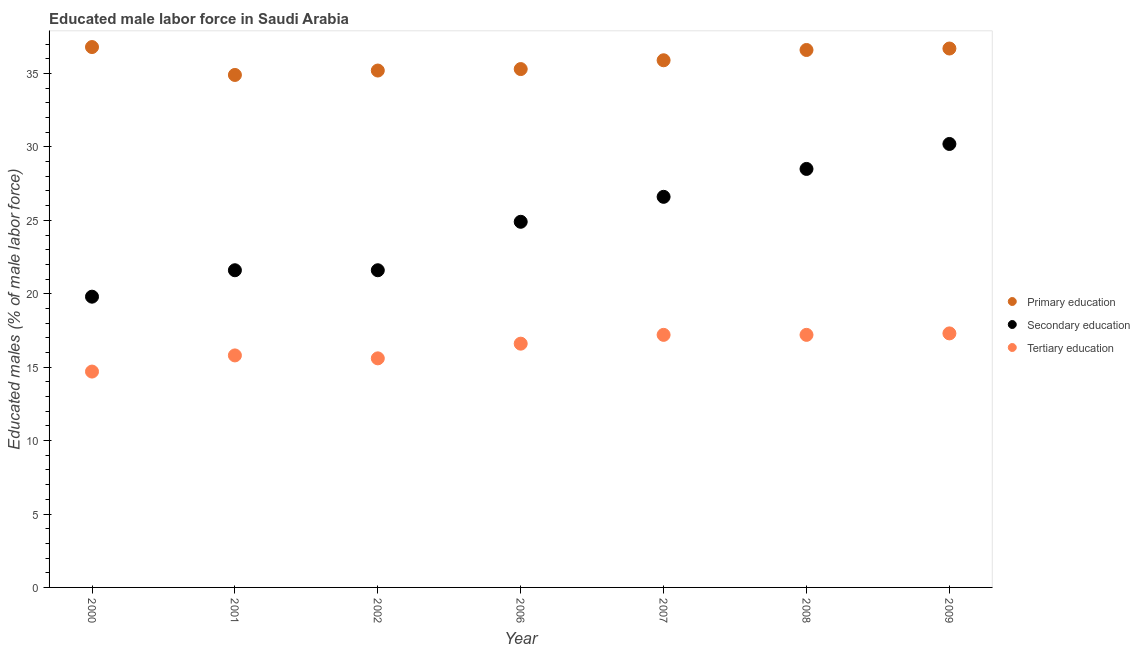Is the number of dotlines equal to the number of legend labels?
Provide a succinct answer. Yes. What is the percentage of male labor force who received primary education in 2002?
Provide a short and direct response. 35.2. Across all years, what is the maximum percentage of male labor force who received primary education?
Make the answer very short. 36.8. Across all years, what is the minimum percentage of male labor force who received secondary education?
Your answer should be compact. 19.8. In which year was the percentage of male labor force who received secondary education maximum?
Keep it short and to the point. 2009. In which year was the percentage of male labor force who received secondary education minimum?
Give a very brief answer. 2000. What is the total percentage of male labor force who received primary education in the graph?
Offer a very short reply. 251.4. What is the difference between the percentage of male labor force who received primary education in 2002 and that in 2006?
Offer a very short reply. -0.1. What is the difference between the percentage of male labor force who received tertiary education in 2007 and the percentage of male labor force who received primary education in 2002?
Ensure brevity in your answer.  -18. What is the average percentage of male labor force who received tertiary education per year?
Make the answer very short. 16.34. In the year 2000, what is the difference between the percentage of male labor force who received tertiary education and percentage of male labor force who received secondary education?
Keep it short and to the point. -5.1. In how many years, is the percentage of male labor force who received tertiary education greater than 13 %?
Offer a very short reply. 7. What is the ratio of the percentage of male labor force who received secondary education in 2002 to that in 2008?
Make the answer very short. 0.76. Is the percentage of male labor force who received secondary education in 2006 less than that in 2009?
Keep it short and to the point. Yes. Is the difference between the percentage of male labor force who received tertiary education in 2006 and 2008 greater than the difference between the percentage of male labor force who received secondary education in 2006 and 2008?
Offer a terse response. Yes. What is the difference between the highest and the second highest percentage of male labor force who received primary education?
Give a very brief answer. 0.1. What is the difference between the highest and the lowest percentage of male labor force who received primary education?
Make the answer very short. 1.9. Is the percentage of male labor force who received secondary education strictly less than the percentage of male labor force who received tertiary education over the years?
Provide a short and direct response. No. How many dotlines are there?
Your response must be concise. 3. Are the values on the major ticks of Y-axis written in scientific E-notation?
Give a very brief answer. No. Does the graph contain grids?
Offer a very short reply. No. Where does the legend appear in the graph?
Your answer should be compact. Center right. How are the legend labels stacked?
Make the answer very short. Vertical. What is the title of the graph?
Your answer should be very brief. Educated male labor force in Saudi Arabia. Does "Domestic" appear as one of the legend labels in the graph?
Give a very brief answer. No. What is the label or title of the X-axis?
Provide a short and direct response. Year. What is the label or title of the Y-axis?
Give a very brief answer. Educated males (% of male labor force). What is the Educated males (% of male labor force) of Primary education in 2000?
Your response must be concise. 36.8. What is the Educated males (% of male labor force) in Secondary education in 2000?
Your answer should be compact. 19.8. What is the Educated males (% of male labor force) in Tertiary education in 2000?
Ensure brevity in your answer.  14.7. What is the Educated males (% of male labor force) of Primary education in 2001?
Your answer should be compact. 34.9. What is the Educated males (% of male labor force) of Secondary education in 2001?
Your answer should be compact. 21.6. What is the Educated males (% of male labor force) in Tertiary education in 2001?
Make the answer very short. 15.8. What is the Educated males (% of male labor force) of Primary education in 2002?
Your answer should be compact. 35.2. What is the Educated males (% of male labor force) of Secondary education in 2002?
Provide a succinct answer. 21.6. What is the Educated males (% of male labor force) in Tertiary education in 2002?
Provide a succinct answer. 15.6. What is the Educated males (% of male labor force) in Primary education in 2006?
Your answer should be very brief. 35.3. What is the Educated males (% of male labor force) in Secondary education in 2006?
Give a very brief answer. 24.9. What is the Educated males (% of male labor force) of Tertiary education in 2006?
Provide a short and direct response. 16.6. What is the Educated males (% of male labor force) in Primary education in 2007?
Your response must be concise. 35.9. What is the Educated males (% of male labor force) in Secondary education in 2007?
Make the answer very short. 26.6. What is the Educated males (% of male labor force) of Tertiary education in 2007?
Your answer should be very brief. 17.2. What is the Educated males (% of male labor force) of Primary education in 2008?
Offer a very short reply. 36.6. What is the Educated males (% of male labor force) of Secondary education in 2008?
Keep it short and to the point. 28.5. What is the Educated males (% of male labor force) of Tertiary education in 2008?
Your answer should be compact. 17.2. What is the Educated males (% of male labor force) in Primary education in 2009?
Keep it short and to the point. 36.7. What is the Educated males (% of male labor force) in Secondary education in 2009?
Ensure brevity in your answer.  30.2. What is the Educated males (% of male labor force) of Tertiary education in 2009?
Ensure brevity in your answer.  17.3. Across all years, what is the maximum Educated males (% of male labor force) in Primary education?
Your response must be concise. 36.8. Across all years, what is the maximum Educated males (% of male labor force) of Secondary education?
Ensure brevity in your answer.  30.2. Across all years, what is the maximum Educated males (% of male labor force) in Tertiary education?
Your answer should be compact. 17.3. Across all years, what is the minimum Educated males (% of male labor force) in Primary education?
Keep it short and to the point. 34.9. Across all years, what is the minimum Educated males (% of male labor force) of Secondary education?
Offer a very short reply. 19.8. Across all years, what is the minimum Educated males (% of male labor force) in Tertiary education?
Make the answer very short. 14.7. What is the total Educated males (% of male labor force) in Primary education in the graph?
Your response must be concise. 251.4. What is the total Educated males (% of male labor force) in Secondary education in the graph?
Your response must be concise. 173.2. What is the total Educated males (% of male labor force) in Tertiary education in the graph?
Your answer should be compact. 114.4. What is the difference between the Educated males (% of male labor force) of Tertiary education in 2000 and that in 2002?
Offer a very short reply. -0.9. What is the difference between the Educated males (% of male labor force) in Primary education in 2000 and that in 2007?
Give a very brief answer. 0.9. What is the difference between the Educated males (% of male labor force) of Tertiary education in 2000 and that in 2007?
Your answer should be compact. -2.5. What is the difference between the Educated males (% of male labor force) in Primary education in 2000 and that in 2008?
Your response must be concise. 0.2. What is the difference between the Educated males (% of male labor force) of Tertiary education in 2000 and that in 2008?
Provide a short and direct response. -2.5. What is the difference between the Educated males (% of male labor force) of Primary education in 2000 and that in 2009?
Offer a terse response. 0.1. What is the difference between the Educated males (% of male labor force) in Secondary education in 2000 and that in 2009?
Make the answer very short. -10.4. What is the difference between the Educated males (% of male labor force) of Secondary education in 2001 and that in 2002?
Provide a succinct answer. 0. What is the difference between the Educated males (% of male labor force) in Tertiary education in 2001 and that in 2002?
Ensure brevity in your answer.  0.2. What is the difference between the Educated males (% of male labor force) in Primary education in 2001 and that in 2006?
Make the answer very short. -0.4. What is the difference between the Educated males (% of male labor force) in Primary education in 2001 and that in 2007?
Make the answer very short. -1. What is the difference between the Educated males (% of male labor force) of Secondary education in 2001 and that in 2007?
Your response must be concise. -5. What is the difference between the Educated males (% of male labor force) of Tertiary education in 2001 and that in 2007?
Make the answer very short. -1.4. What is the difference between the Educated males (% of male labor force) of Secondary education in 2001 and that in 2008?
Your answer should be very brief. -6.9. What is the difference between the Educated males (% of male labor force) of Secondary education in 2001 and that in 2009?
Your answer should be compact. -8.6. What is the difference between the Educated males (% of male labor force) of Tertiary education in 2002 and that in 2006?
Keep it short and to the point. -1. What is the difference between the Educated males (% of male labor force) in Primary education in 2002 and that in 2008?
Make the answer very short. -1.4. What is the difference between the Educated males (% of male labor force) in Tertiary education in 2002 and that in 2008?
Your answer should be compact. -1.6. What is the difference between the Educated males (% of male labor force) of Tertiary education in 2002 and that in 2009?
Give a very brief answer. -1.7. What is the difference between the Educated males (% of male labor force) of Secondary education in 2006 and that in 2007?
Provide a short and direct response. -1.7. What is the difference between the Educated males (% of male labor force) of Tertiary education in 2006 and that in 2007?
Your answer should be compact. -0.6. What is the difference between the Educated males (% of male labor force) of Primary education in 2006 and that in 2008?
Give a very brief answer. -1.3. What is the difference between the Educated males (% of male labor force) of Secondary education in 2006 and that in 2008?
Keep it short and to the point. -3.6. What is the difference between the Educated males (% of male labor force) in Primary education in 2007 and that in 2008?
Offer a terse response. -0.7. What is the difference between the Educated males (% of male labor force) of Secondary education in 2007 and that in 2008?
Give a very brief answer. -1.9. What is the difference between the Educated males (% of male labor force) of Tertiary education in 2007 and that in 2008?
Your answer should be compact. 0. What is the difference between the Educated males (% of male labor force) of Primary education in 2007 and that in 2009?
Ensure brevity in your answer.  -0.8. What is the difference between the Educated males (% of male labor force) of Secondary education in 2007 and that in 2009?
Keep it short and to the point. -3.6. What is the difference between the Educated males (% of male labor force) of Primary education in 2008 and that in 2009?
Provide a short and direct response. -0.1. What is the difference between the Educated males (% of male labor force) in Secondary education in 2008 and that in 2009?
Your response must be concise. -1.7. What is the difference between the Educated males (% of male labor force) in Primary education in 2000 and the Educated males (% of male labor force) in Secondary education in 2001?
Offer a terse response. 15.2. What is the difference between the Educated males (% of male labor force) of Primary education in 2000 and the Educated males (% of male labor force) of Tertiary education in 2001?
Make the answer very short. 21. What is the difference between the Educated males (% of male labor force) in Secondary education in 2000 and the Educated males (% of male labor force) in Tertiary education in 2001?
Keep it short and to the point. 4. What is the difference between the Educated males (% of male labor force) in Primary education in 2000 and the Educated males (% of male labor force) in Tertiary education in 2002?
Keep it short and to the point. 21.2. What is the difference between the Educated males (% of male labor force) of Secondary education in 2000 and the Educated males (% of male labor force) of Tertiary education in 2002?
Make the answer very short. 4.2. What is the difference between the Educated males (% of male labor force) in Primary education in 2000 and the Educated males (% of male labor force) in Tertiary education in 2006?
Keep it short and to the point. 20.2. What is the difference between the Educated males (% of male labor force) in Secondary education in 2000 and the Educated males (% of male labor force) in Tertiary education in 2006?
Your answer should be very brief. 3.2. What is the difference between the Educated males (% of male labor force) of Primary education in 2000 and the Educated males (% of male labor force) of Tertiary education in 2007?
Provide a succinct answer. 19.6. What is the difference between the Educated males (% of male labor force) in Secondary education in 2000 and the Educated males (% of male labor force) in Tertiary education in 2007?
Offer a terse response. 2.6. What is the difference between the Educated males (% of male labor force) of Primary education in 2000 and the Educated males (% of male labor force) of Tertiary education in 2008?
Your answer should be very brief. 19.6. What is the difference between the Educated males (% of male labor force) in Secondary education in 2000 and the Educated males (% of male labor force) in Tertiary education in 2008?
Keep it short and to the point. 2.6. What is the difference between the Educated males (% of male labor force) of Primary education in 2000 and the Educated males (% of male labor force) of Secondary education in 2009?
Keep it short and to the point. 6.6. What is the difference between the Educated males (% of male labor force) in Primary education in 2000 and the Educated males (% of male labor force) in Tertiary education in 2009?
Your response must be concise. 19.5. What is the difference between the Educated males (% of male labor force) of Secondary education in 2000 and the Educated males (% of male labor force) of Tertiary education in 2009?
Provide a succinct answer. 2.5. What is the difference between the Educated males (% of male labor force) in Primary education in 2001 and the Educated males (% of male labor force) in Tertiary education in 2002?
Your answer should be very brief. 19.3. What is the difference between the Educated males (% of male labor force) in Secondary education in 2001 and the Educated males (% of male labor force) in Tertiary education in 2002?
Make the answer very short. 6. What is the difference between the Educated males (% of male labor force) in Primary education in 2001 and the Educated males (% of male labor force) in Tertiary education in 2006?
Ensure brevity in your answer.  18.3. What is the difference between the Educated males (% of male labor force) in Primary education in 2001 and the Educated males (% of male labor force) in Secondary education in 2007?
Your response must be concise. 8.3. What is the difference between the Educated males (% of male labor force) in Primary education in 2001 and the Educated males (% of male labor force) in Tertiary education in 2007?
Give a very brief answer. 17.7. What is the difference between the Educated males (% of male labor force) in Primary education in 2001 and the Educated males (% of male labor force) in Secondary education in 2008?
Your answer should be very brief. 6.4. What is the difference between the Educated males (% of male labor force) in Primary education in 2001 and the Educated males (% of male labor force) in Tertiary education in 2008?
Offer a terse response. 17.7. What is the difference between the Educated males (% of male labor force) in Secondary education in 2001 and the Educated males (% of male labor force) in Tertiary education in 2008?
Make the answer very short. 4.4. What is the difference between the Educated males (% of male labor force) in Primary education in 2001 and the Educated males (% of male labor force) in Secondary education in 2009?
Your response must be concise. 4.7. What is the difference between the Educated males (% of male labor force) in Primary education in 2001 and the Educated males (% of male labor force) in Tertiary education in 2009?
Offer a very short reply. 17.6. What is the difference between the Educated males (% of male labor force) of Secondary education in 2001 and the Educated males (% of male labor force) of Tertiary education in 2009?
Your response must be concise. 4.3. What is the difference between the Educated males (% of male labor force) of Primary education in 2002 and the Educated males (% of male labor force) of Secondary education in 2006?
Make the answer very short. 10.3. What is the difference between the Educated males (% of male labor force) in Primary education in 2002 and the Educated males (% of male labor force) in Tertiary education in 2006?
Your answer should be compact. 18.6. What is the difference between the Educated males (% of male labor force) in Primary education in 2002 and the Educated males (% of male labor force) in Tertiary education in 2007?
Offer a very short reply. 18. What is the difference between the Educated males (% of male labor force) in Secondary education in 2002 and the Educated males (% of male labor force) in Tertiary education in 2007?
Make the answer very short. 4.4. What is the difference between the Educated males (% of male labor force) of Primary education in 2002 and the Educated males (% of male labor force) of Secondary education in 2008?
Give a very brief answer. 6.7. What is the difference between the Educated males (% of male labor force) in Primary education in 2002 and the Educated males (% of male labor force) in Secondary education in 2009?
Offer a very short reply. 5. What is the difference between the Educated males (% of male labor force) of Primary education in 2002 and the Educated males (% of male labor force) of Tertiary education in 2009?
Offer a terse response. 17.9. What is the difference between the Educated males (% of male labor force) of Secondary education in 2002 and the Educated males (% of male labor force) of Tertiary education in 2009?
Offer a terse response. 4.3. What is the difference between the Educated males (% of male labor force) of Primary education in 2006 and the Educated males (% of male labor force) of Tertiary education in 2007?
Provide a short and direct response. 18.1. What is the difference between the Educated males (% of male labor force) of Secondary education in 2006 and the Educated males (% of male labor force) of Tertiary education in 2007?
Ensure brevity in your answer.  7.7. What is the difference between the Educated males (% of male labor force) in Primary education in 2006 and the Educated males (% of male labor force) in Secondary education in 2008?
Keep it short and to the point. 6.8. What is the difference between the Educated males (% of male labor force) in Primary education in 2006 and the Educated males (% of male labor force) in Tertiary education in 2009?
Provide a short and direct response. 18. What is the difference between the Educated males (% of male labor force) in Secondary education in 2006 and the Educated males (% of male labor force) in Tertiary education in 2009?
Offer a very short reply. 7.6. What is the difference between the Educated males (% of male labor force) of Primary education in 2007 and the Educated males (% of male labor force) of Secondary education in 2008?
Offer a very short reply. 7.4. What is the difference between the Educated males (% of male labor force) in Secondary education in 2007 and the Educated males (% of male labor force) in Tertiary education in 2008?
Your answer should be compact. 9.4. What is the difference between the Educated males (% of male labor force) in Secondary education in 2007 and the Educated males (% of male labor force) in Tertiary education in 2009?
Your answer should be compact. 9.3. What is the difference between the Educated males (% of male labor force) of Primary education in 2008 and the Educated males (% of male labor force) of Secondary education in 2009?
Offer a very short reply. 6.4. What is the difference between the Educated males (% of male labor force) in Primary education in 2008 and the Educated males (% of male labor force) in Tertiary education in 2009?
Make the answer very short. 19.3. What is the average Educated males (% of male labor force) of Primary education per year?
Ensure brevity in your answer.  35.91. What is the average Educated males (% of male labor force) in Secondary education per year?
Keep it short and to the point. 24.74. What is the average Educated males (% of male labor force) in Tertiary education per year?
Keep it short and to the point. 16.34. In the year 2000, what is the difference between the Educated males (% of male labor force) in Primary education and Educated males (% of male labor force) in Tertiary education?
Provide a succinct answer. 22.1. In the year 2000, what is the difference between the Educated males (% of male labor force) in Secondary education and Educated males (% of male labor force) in Tertiary education?
Your response must be concise. 5.1. In the year 2001, what is the difference between the Educated males (% of male labor force) of Primary education and Educated males (% of male labor force) of Secondary education?
Ensure brevity in your answer.  13.3. In the year 2001, what is the difference between the Educated males (% of male labor force) in Secondary education and Educated males (% of male labor force) in Tertiary education?
Offer a terse response. 5.8. In the year 2002, what is the difference between the Educated males (% of male labor force) in Primary education and Educated males (% of male labor force) in Secondary education?
Make the answer very short. 13.6. In the year 2002, what is the difference between the Educated males (% of male labor force) in Primary education and Educated males (% of male labor force) in Tertiary education?
Make the answer very short. 19.6. In the year 2002, what is the difference between the Educated males (% of male labor force) of Secondary education and Educated males (% of male labor force) of Tertiary education?
Provide a short and direct response. 6. In the year 2006, what is the difference between the Educated males (% of male labor force) in Primary education and Educated males (% of male labor force) in Secondary education?
Your answer should be compact. 10.4. In the year 2007, what is the difference between the Educated males (% of male labor force) in Primary education and Educated males (% of male labor force) in Tertiary education?
Your answer should be very brief. 18.7. In the year 2007, what is the difference between the Educated males (% of male labor force) in Secondary education and Educated males (% of male labor force) in Tertiary education?
Provide a succinct answer. 9.4. In the year 2009, what is the difference between the Educated males (% of male labor force) of Primary education and Educated males (% of male labor force) of Secondary education?
Make the answer very short. 6.5. In the year 2009, what is the difference between the Educated males (% of male labor force) of Primary education and Educated males (% of male labor force) of Tertiary education?
Ensure brevity in your answer.  19.4. In the year 2009, what is the difference between the Educated males (% of male labor force) of Secondary education and Educated males (% of male labor force) of Tertiary education?
Ensure brevity in your answer.  12.9. What is the ratio of the Educated males (% of male labor force) in Primary education in 2000 to that in 2001?
Make the answer very short. 1.05. What is the ratio of the Educated males (% of male labor force) in Tertiary education in 2000 to that in 2001?
Your answer should be very brief. 0.93. What is the ratio of the Educated males (% of male labor force) of Primary education in 2000 to that in 2002?
Make the answer very short. 1.05. What is the ratio of the Educated males (% of male labor force) of Secondary education in 2000 to that in 2002?
Ensure brevity in your answer.  0.92. What is the ratio of the Educated males (% of male labor force) in Tertiary education in 2000 to that in 2002?
Make the answer very short. 0.94. What is the ratio of the Educated males (% of male labor force) in Primary education in 2000 to that in 2006?
Offer a terse response. 1.04. What is the ratio of the Educated males (% of male labor force) of Secondary education in 2000 to that in 2006?
Your answer should be compact. 0.8. What is the ratio of the Educated males (% of male labor force) in Tertiary education in 2000 to that in 2006?
Offer a terse response. 0.89. What is the ratio of the Educated males (% of male labor force) of Primary education in 2000 to that in 2007?
Offer a terse response. 1.03. What is the ratio of the Educated males (% of male labor force) in Secondary education in 2000 to that in 2007?
Give a very brief answer. 0.74. What is the ratio of the Educated males (% of male labor force) of Tertiary education in 2000 to that in 2007?
Offer a terse response. 0.85. What is the ratio of the Educated males (% of male labor force) of Primary education in 2000 to that in 2008?
Your response must be concise. 1.01. What is the ratio of the Educated males (% of male labor force) in Secondary education in 2000 to that in 2008?
Your answer should be compact. 0.69. What is the ratio of the Educated males (% of male labor force) of Tertiary education in 2000 to that in 2008?
Provide a short and direct response. 0.85. What is the ratio of the Educated males (% of male labor force) of Primary education in 2000 to that in 2009?
Provide a succinct answer. 1. What is the ratio of the Educated males (% of male labor force) in Secondary education in 2000 to that in 2009?
Make the answer very short. 0.66. What is the ratio of the Educated males (% of male labor force) of Tertiary education in 2000 to that in 2009?
Ensure brevity in your answer.  0.85. What is the ratio of the Educated males (% of male labor force) of Primary education in 2001 to that in 2002?
Your answer should be very brief. 0.99. What is the ratio of the Educated males (% of male labor force) in Tertiary education in 2001 to that in 2002?
Offer a terse response. 1.01. What is the ratio of the Educated males (% of male labor force) of Primary education in 2001 to that in 2006?
Offer a terse response. 0.99. What is the ratio of the Educated males (% of male labor force) in Secondary education in 2001 to that in 2006?
Provide a succinct answer. 0.87. What is the ratio of the Educated males (% of male labor force) of Tertiary education in 2001 to that in 2006?
Make the answer very short. 0.95. What is the ratio of the Educated males (% of male labor force) in Primary education in 2001 to that in 2007?
Provide a succinct answer. 0.97. What is the ratio of the Educated males (% of male labor force) in Secondary education in 2001 to that in 2007?
Provide a succinct answer. 0.81. What is the ratio of the Educated males (% of male labor force) in Tertiary education in 2001 to that in 2007?
Offer a very short reply. 0.92. What is the ratio of the Educated males (% of male labor force) in Primary education in 2001 to that in 2008?
Your response must be concise. 0.95. What is the ratio of the Educated males (% of male labor force) in Secondary education in 2001 to that in 2008?
Your answer should be very brief. 0.76. What is the ratio of the Educated males (% of male labor force) in Tertiary education in 2001 to that in 2008?
Your response must be concise. 0.92. What is the ratio of the Educated males (% of male labor force) in Primary education in 2001 to that in 2009?
Your answer should be very brief. 0.95. What is the ratio of the Educated males (% of male labor force) of Secondary education in 2001 to that in 2009?
Offer a terse response. 0.72. What is the ratio of the Educated males (% of male labor force) in Tertiary education in 2001 to that in 2009?
Provide a succinct answer. 0.91. What is the ratio of the Educated males (% of male labor force) of Secondary education in 2002 to that in 2006?
Ensure brevity in your answer.  0.87. What is the ratio of the Educated males (% of male labor force) in Tertiary education in 2002 to that in 2006?
Offer a terse response. 0.94. What is the ratio of the Educated males (% of male labor force) of Primary education in 2002 to that in 2007?
Your answer should be very brief. 0.98. What is the ratio of the Educated males (% of male labor force) in Secondary education in 2002 to that in 2007?
Your response must be concise. 0.81. What is the ratio of the Educated males (% of male labor force) in Tertiary education in 2002 to that in 2007?
Give a very brief answer. 0.91. What is the ratio of the Educated males (% of male labor force) of Primary education in 2002 to that in 2008?
Offer a very short reply. 0.96. What is the ratio of the Educated males (% of male labor force) of Secondary education in 2002 to that in 2008?
Give a very brief answer. 0.76. What is the ratio of the Educated males (% of male labor force) of Tertiary education in 2002 to that in 2008?
Keep it short and to the point. 0.91. What is the ratio of the Educated males (% of male labor force) in Primary education in 2002 to that in 2009?
Your answer should be very brief. 0.96. What is the ratio of the Educated males (% of male labor force) of Secondary education in 2002 to that in 2009?
Offer a terse response. 0.72. What is the ratio of the Educated males (% of male labor force) in Tertiary education in 2002 to that in 2009?
Your response must be concise. 0.9. What is the ratio of the Educated males (% of male labor force) of Primary education in 2006 to that in 2007?
Your answer should be very brief. 0.98. What is the ratio of the Educated males (% of male labor force) in Secondary education in 2006 to that in 2007?
Offer a very short reply. 0.94. What is the ratio of the Educated males (% of male labor force) in Tertiary education in 2006 to that in 2007?
Provide a short and direct response. 0.97. What is the ratio of the Educated males (% of male labor force) of Primary education in 2006 to that in 2008?
Your answer should be very brief. 0.96. What is the ratio of the Educated males (% of male labor force) in Secondary education in 2006 to that in 2008?
Keep it short and to the point. 0.87. What is the ratio of the Educated males (% of male labor force) of Tertiary education in 2006 to that in 2008?
Your response must be concise. 0.97. What is the ratio of the Educated males (% of male labor force) in Primary education in 2006 to that in 2009?
Provide a succinct answer. 0.96. What is the ratio of the Educated males (% of male labor force) of Secondary education in 2006 to that in 2009?
Your response must be concise. 0.82. What is the ratio of the Educated males (% of male labor force) of Tertiary education in 2006 to that in 2009?
Your answer should be compact. 0.96. What is the ratio of the Educated males (% of male labor force) in Primary education in 2007 to that in 2008?
Give a very brief answer. 0.98. What is the ratio of the Educated males (% of male labor force) in Secondary education in 2007 to that in 2008?
Offer a terse response. 0.93. What is the ratio of the Educated males (% of male labor force) of Primary education in 2007 to that in 2009?
Give a very brief answer. 0.98. What is the ratio of the Educated males (% of male labor force) in Secondary education in 2007 to that in 2009?
Offer a terse response. 0.88. What is the ratio of the Educated males (% of male labor force) in Secondary education in 2008 to that in 2009?
Ensure brevity in your answer.  0.94. What is the ratio of the Educated males (% of male labor force) of Tertiary education in 2008 to that in 2009?
Give a very brief answer. 0.99. What is the difference between the highest and the second highest Educated males (% of male labor force) in Primary education?
Give a very brief answer. 0.1. What is the difference between the highest and the lowest Educated males (% of male labor force) of Secondary education?
Give a very brief answer. 10.4. What is the difference between the highest and the lowest Educated males (% of male labor force) of Tertiary education?
Give a very brief answer. 2.6. 